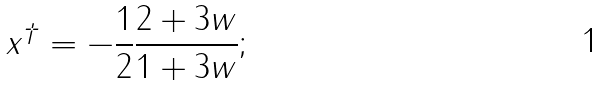Convert formula to latex. <formula><loc_0><loc_0><loc_500><loc_500>x ^ { \dagger } = - \frac { 1 } { 2 } \frac { 2 + 3 w } { 1 + 3 w } ;</formula> 